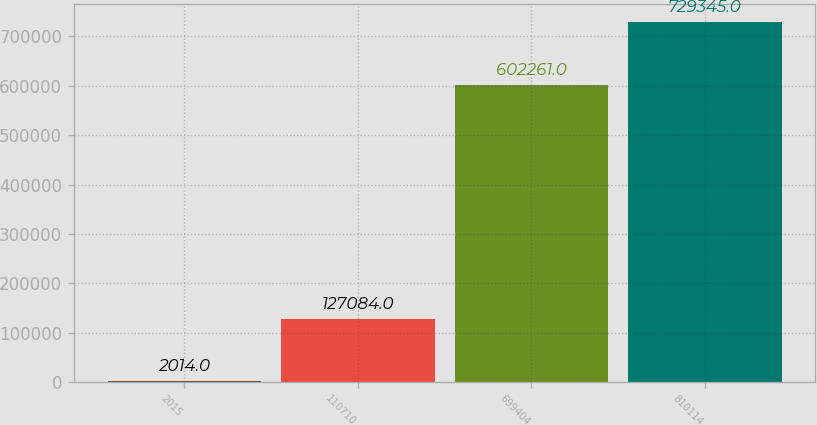Convert chart to OTSL. <chart><loc_0><loc_0><loc_500><loc_500><bar_chart><fcel>2015<fcel>110710<fcel>699404<fcel>810114<nl><fcel>2014<fcel>127084<fcel>602261<fcel>729345<nl></chart> 